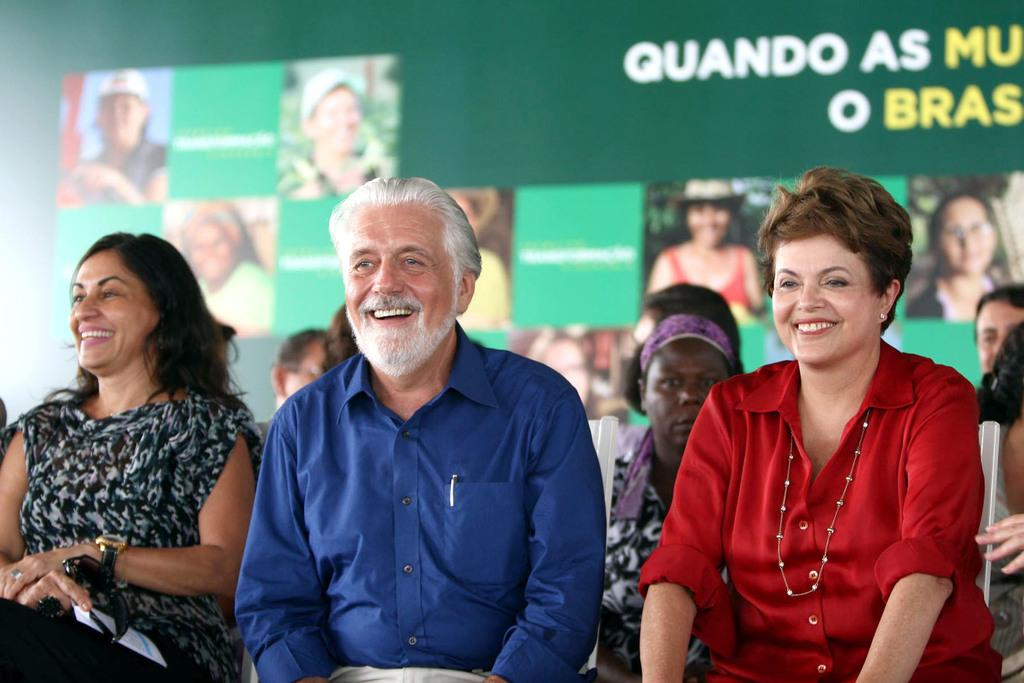What are the people in the image doing? The people in the image are sitting on chairs. What is the facial expression of the people in the image? The people are smiling. What can be seen in the background of the image? There is a banner in the background of the image. Reasoning: Let'ing: Let's think step by step in order to produce the conversation. We start by identifying the main subjects in the image, which are the people sitting on chairs. Then, we describe their actions and expressions, noting that they are smiling. Finally, we mention the presence of a banner in the background, which adds context to the scene. Each question is designed to elicit a specific detail about the image that is known from the provided facts. Absurd Question/Answer: What type of tail can be seen on the people in the image? There are no tails visible on the people in the image. What is the rate of expansion of the chairs in the image? The chairs in the image are not expanding; they are stationary. 